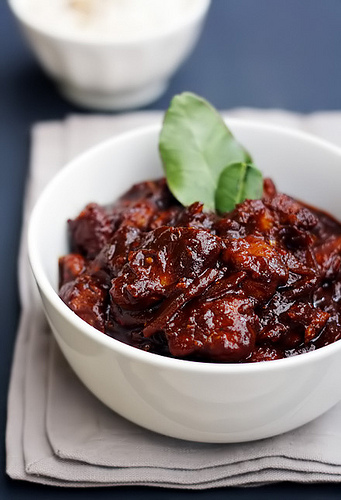<image>
Is there a leaf in the bowl? No. The leaf is not contained within the bowl. These objects have a different spatial relationship. 